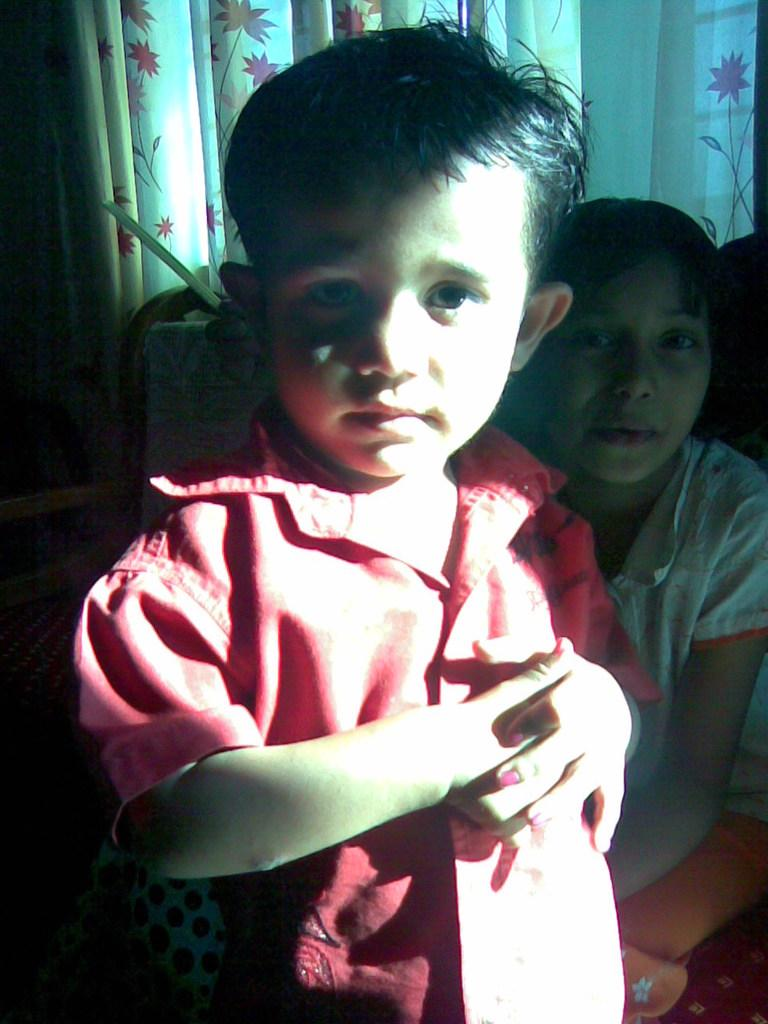How many children are in the image? There are two children in the image. What is the child wearing on the left side of the image wearing? The child on the left side of the image is wearing a red dress. What can be seen in the background of the image? There is a colorful curtain visible in the image. What type of behavior is the library exhibiting in the image? There is no library present in the image, so it is not possible to determine any behavior. 